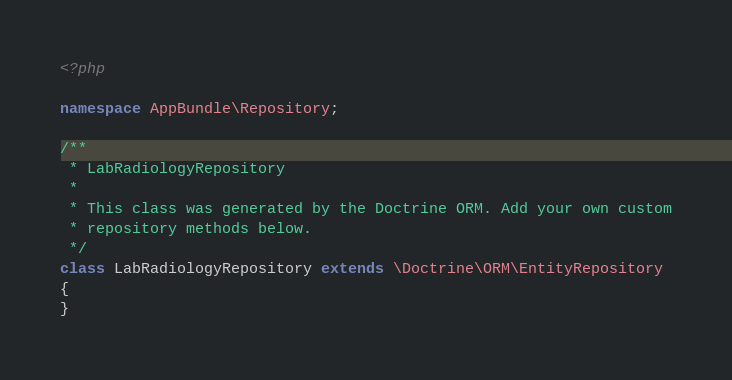Convert code to text. <code><loc_0><loc_0><loc_500><loc_500><_PHP_><?php

namespace AppBundle\Repository;

/**
 * LabRadiologyRepository
 *
 * This class was generated by the Doctrine ORM. Add your own custom
 * repository methods below.
 */
class LabRadiologyRepository extends \Doctrine\ORM\EntityRepository
{
}
</code> 